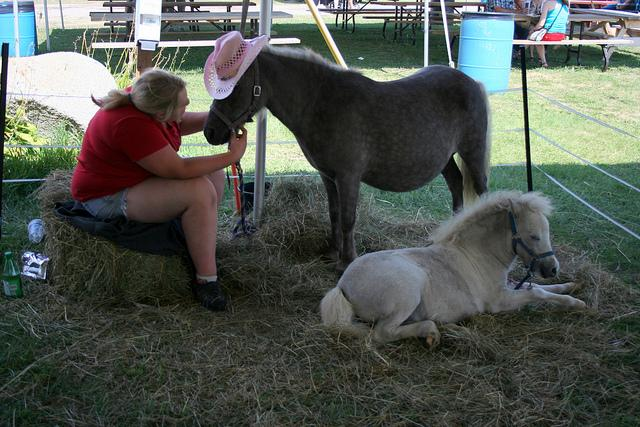The woman is putting what piece of her safety riding gear on the pony? harness 